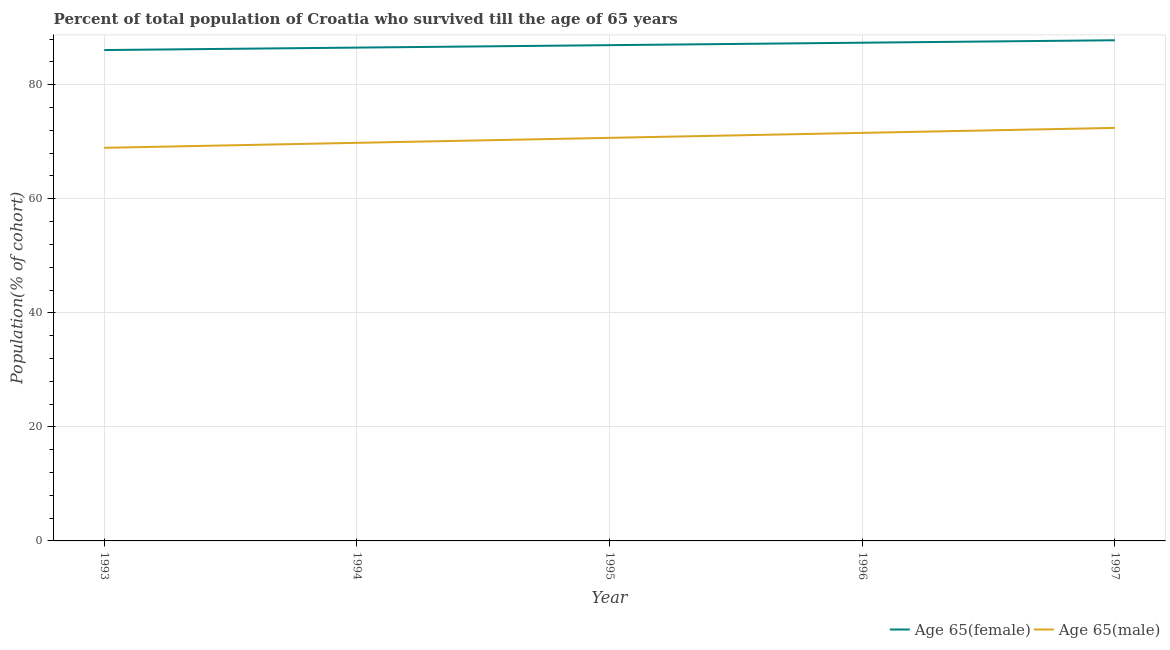Does the line corresponding to percentage of female population who survived till age of 65 intersect with the line corresponding to percentage of male population who survived till age of 65?
Keep it short and to the point. No. Is the number of lines equal to the number of legend labels?
Offer a very short reply. Yes. What is the percentage of female population who survived till age of 65 in 1993?
Your response must be concise. 86.08. Across all years, what is the maximum percentage of female population who survived till age of 65?
Offer a terse response. 87.8. Across all years, what is the minimum percentage of female population who survived till age of 65?
Your answer should be compact. 86.08. In which year was the percentage of female population who survived till age of 65 maximum?
Ensure brevity in your answer.  1997. What is the total percentage of male population who survived till age of 65 in the graph?
Provide a short and direct response. 353.41. What is the difference between the percentage of female population who survived till age of 65 in 1993 and that in 1996?
Provide a short and direct response. -1.29. What is the difference between the percentage of female population who survived till age of 65 in 1993 and the percentage of male population who survived till age of 65 in 1995?
Your answer should be compact. 15.4. What is the average percentage of male population who survived till age of 65 per year?
Provide a succinct answer. 70.68. In the year 1993, what is the difference between the percentage of female population who survived till age of 65 and percentage of male population who survived till age of 65?
Offer a terse response. 17.14. What is the ratio of the percentage of female population who survived till age of 65 in 1993 to that in 1994?
Offer a terse response. 1. Is the percentage of female population who survived till age of 65 in 1996 less than that in 1997?
Your answer should be very brief. Yes. Is the difference between the percentage of male population who survived till age of 65 in 1995 and 1997 greater than the difference between the percentage of female population who survived till age of 65 in 1995 and 1997?
Your answer should be compact. No. What is the difference between the highest and the second highest percentage of female population who survived till age of 65?
Offer a terse response. 0.43. What is the difference between the highest and the lowest percentage of female population who survived till age of 65?
Keep it short and to the point. 1.72. Is the sum of the percentage of female population who survived till age of 65 in 1994 and 1996 greater than the maximum percentage of male population who survived till age of 65 across all years?
Provide a short and direct response. Yes. Is the percentage of male population who survived till age of 65 strictly less than the percentage of female population who survived till age of 65 over the years?
Your answer should be very brief. Yes. How many lines are there?
Ensure brevity in your answer.  2. Does the graph contain grids?
Make the answer very short. Yes. How many legend labels are there?
Keep it short and to the point. 2. How are the legend labels stacked?
Provide a succinct answer. Horizontal. What is the title of the graph?
Keep it short and to the point. Percent of total population of Croatia who survived till the age of 65 years. What is the label or title of the X-axis?
Ensure brevity in your answer.  Year. What is the label or title of the Y-axis?
Your answer should be very brief. Population(% of cohort). What is the Population(% of cohort) of Age 65(female) in 1993?
Give a very brief answer. 86.08. What is the Population(% of cohort) of Age 65(male) in 1993?
Make the answer very short. 68.94. What is the Population(% of cohort) in Age 65(female) in 1994?
Provide a succinct answer. 86.51. What is the Population(% of cohort) of Age 65(male) in 1994?
Your answer should be very brief. 69.81. What is the Population(% of cohort) of Age 65(female) in 1995?
Give a very brief answer. 86.94. What is the Population(% of cohort) in Age 65(male) in 1995?
Offer a very short reply. 70.68. What is the Population(% of cohort) in Age 65(female) in 1996?
Offer a very short reply. 87.37. What is the Population(% of cohort) of Age 65(male) in 1996?
Your answer should be compact. 71.55. What is the Population(% of cohort) of Age 65(female) in 1997?
Offer a very short reply. 87.8. What is the Population(% of cohort) in Age 65(male) in 1997?
Offer a terse response. 72.43. Across all years, what is the maximum Population(% of cohort) in Age 65(female)?
Make the answer very short. 87.8. Across all years, what is the maximum Population(% of cohort) of Age 65(male)?
Give a very brief answer. 72.43. Across all years, what is the minimum Population(% of cohort) in Age 65(female)?
Provide a succinct answer. 86.08. Across all years, what is the minimum Population(% of cohort) in Age 65(male)?
Offer a very short reply. 68.94. What is the total Population(% of cohort) of Age 65(female) in the graph?
Your answer should be compact. 434.68. What is the total Population(% of cohort) in Age 65(male) in the graph?
Provide a short and direct response. 353.41. What is the difference between the Population(% of cohort) in Age 65(female) in 1993 and that in 1994?
Your response must be concise. -0.43. What is the difference between the Population(% of cohort) in Age 65(male) in 1993 and that in 1994?
Provide a succinct answer. -0.87. What is the difference between the Population(% of cohort) in Age 65(female) in 1993 and that in 1995?
Your response must be concise. -0.86. What is the difference between the Population(% of cohort) of Age 65(male) in 1993 and that in 1995?
Give a very brief answer. -1.75. What is the difference between the Population(% of cohort) of Age 65(female) in 1993 and that in 1996?
Your answer should be very brief. -1.29. What is the difference between the Population(% of cohort) in Age 65(male) in 1993 and that in 1996?
Give a very brief answer. -2.62. What is the difference between the Population(% of cohort) in Age 65(female) in 1993 and that in 1997?
Your response must be concise. -1.72. What is the difference between the Population(% of cohort) in Age 65(male) in 1993 and that in 1997?
Offer a terse response. -3.49. What is the difference between the Population(% of cohort) in Age 65(female) in 1994 and that in 1995?
Ensure brevity in your answer.  -0.43. What is the difference between the Population(% of cohort) of Age 65(male) in 1994 and that in 1995?
Your answer should be compact. -0.87. What is the difference between the Population(% of cohort) in Age 65(female) in 1994 and that in 1996?
Make the answer very short. -0.86. What is the difference between the Population(% of cohort) of Age 65(male) in 1994 and that in 1996?
Provide a short and direct response. -1.75. What is the difference between the Population(% of cohort) of Age 65(female) in 1994 and that in 1997?
Your response must be concise. -1.29. What is the difference between the Population(% of cohort) of Age 65(male) in 1994 and that in 1997?
Ensure brevity in your answer.  -2.62. What is the difference between the Population(% of cohort) of Age 65(female) in 1995 and that in 1996?
Make the answer very short. -0.43. What is the difference between the Population(% of cohort) in Age 65(male) in 1995 and that in 1996?
Give a very brief answer. -0.87. What is the difference between the Population(% of cohort) in Age 65(female) in 1995 and that in 1997?
Make the answer very short. -0.86. What is the difference between the Population(% of cohort) in Age 65(male) in 1995 and that in 1997?
Ensure brevity in your answer.  -1.75. What is the difference between the Population(% of cohort) in Age 65(female) in 1996 and that in 1997?
Offer a terse response. -0.43. What is the difference between the Population(% of cohort) of Age 65(male) in 1996 and that in 1997?
Your answer should be very brief. -0.87. What is the difference between the Population(% of cohort) of Age 65(female) in 1993 and the Population(% of cohort) of Age 65(male) in 1994?
Keep it short and to the point. 16.27. What is the difference between the Population(% of cohort) in Age 65(female) in 1993 and the Population(% of cohort) in Age 65(male) in 1995?
Your answer should be very brief. 15.4. What is the difference between the Population(% of cohort) of Age 65(female) in 1993 and the Population(% of cohort) of Age 65(male) in 1996?
Provide a succinct answer. 14.52. What is the difference between the Population(% of cohort) in Age 65(female) in 1993 and the Population(% of cohort) in Age 65(male) in 1997?
Your answer should be compact. 13.65. What is the difference between the Population(% of cohort) in Age 65(female) in 1994 and the Population(% of cohort) in Age 65(male) in 1995?
Ensure brevity in your answer.  15.83. What is the difference between the Population(% of cohort) of Age 65(female) in 1994 and the Population(% of cohort) of Age 65(male) in 1996?
Provide a short and direct response. 14.95. What is the difference between the Population(% of cohort) in Age 65(female) in 1994 and the Population(% of cohort) in Age 65(male) in 1997?
Keep it short and to the point. 14.08. What is the difference between the Population(% of cohort) in Age 65(female) in 1995 and the Population(% of cohort) in Age 65(male) in 1996?
Ensure brevity in your answer.  15.38. What is the difference between the Population(% of cohort) of Age 65(female) in 1995 and the Population(% of cohort) of Age 65(male) in 1997?
Offer a very short reply. 14.51. What is the difference between the Population(% of cohort) of Age 65(female) in 1996 and the Population(% of cohort) of Age 65(male) in 1997?
Your answer should be compact. 14.94. What is the average Population(% of cohort) in Age 65(female) per year?
Offer a terse response. 86.94. What is the average Population(% of cohort) in Age 65(male) per year?
Your response must be concise. 70.68. In the year 1993, what is the difference between the Population(% of cohort) of Age 65(female) and Population(% of cohort) of Age 65(male)?
Give a very brief answer. 17.14. In the year 1994, what is the difference between the Population(% of cohort) of Age 65(female) and Population(% of cohort) of Age 65(male)?
Provide a succinct answer. 16.7. In the year 1995, what is the difference between the Population(% of cohort) in Age 65(female) and Population(% of cohort) in Age 65(male)?
Keep it short and to the point. 16.26. In the year 1996, what is the difference between the Population(% of cohort) in Age 65(female) and Population(% of cohort) in Age 65(male)?
Your answer should be compact. 15.81. In the year 1997, what is the difference between the Population(% of cohort) in Age 65(female) and Population(% of cohort) in Age 65(male)?
Offer a very short reply. 15.37. What is the ratio of the Population(% of cohort) in Age 65(male) in 1993 to that in 1994?
Your answer should be compact. 0.99. What is the ratio of the Population(% of cohort) of Age 65(male) in 1993 to that in 1995?
Provide a succinct answer. 0.98. What is the ratio of the Population(% of cohort) of Age 65(male) in 1993 to that in 1996?
Make the answer very short. 0.96. What is the ratio of the Population(% of cohort) in Age 65(female) in 1993 to that in 1997?
Offer a terse response. 0.98. What is the ratio of the Population(% of cohort) of Age 65(male) in 1993 to that in 1997?
Keep it short and to the point. 0.95. What is the ratio of the Population(% of cohort) of Age 65(female) in 1994 to that in 1995?
Make the answer very short. 1. What is the ratio of the Population(% of cohort) in Age 65(male) in 1994 to that in 1995?
Provide a succinct answer. 0.99. What is the ratio of the Population(% of cohort) in Age 65(female) in 1994 to that in 1996?
Offer a very short reply. 0.99. What is the ratio of the Population(% of cohort) in Age 65(male) in 1994 to that in 1996?
Provide a succinct answer. 0.98. What is the ratio of the Population(% of cohort) in Age 65(female) in 1994 to that in 1997?
Your answer should be very brief. 0.99. What is the ratio of the Population(% of cohort) of Age 65(male) in 1994 to that in 1997?
Ensure brevity in your answer.  0.96. What is the ratio of the Population(% of cohort) in Age 65(male) in 1995 to that in 1996?
Your answer should be compact. 0.99. What is the ratio of the Population(% of cohort) in Age 65(female) in 1995 to that in 1997?
Ensure brevity in your answer.  0.99. What is the ratio of the Population(% of cohort) of Age 65(male) in 1995 to that in 1997?
Offer a terse response. 0.98. What is the ratio of the Population(% of cohort) in Age 65(female) in 1996 to that in 1997?
Ensure brevity in your answer.  1. What is the ratio of the Population(% of cohort) in Age 65(male) in 1996 to that in 1997?
Give a very brief answer. 0.99. What is the difference between the highest and the second highest Population(% of cohort) of Age 65(female)?
Keep it short and to the point. 0.43. What is the difference between the highest and the second highest Population(% of cohort) in Age 65(male)?
Offer a very short reply. 0.87. What is the difference between the highest and the lowest Population(% of cohort) in Age 65(female)?
Offer a very short reply. 1.72. What is the difference between the highest and the lowest Population(% of cohort) of Age 65(male)?
Provide a short and direct response. 3.49. 